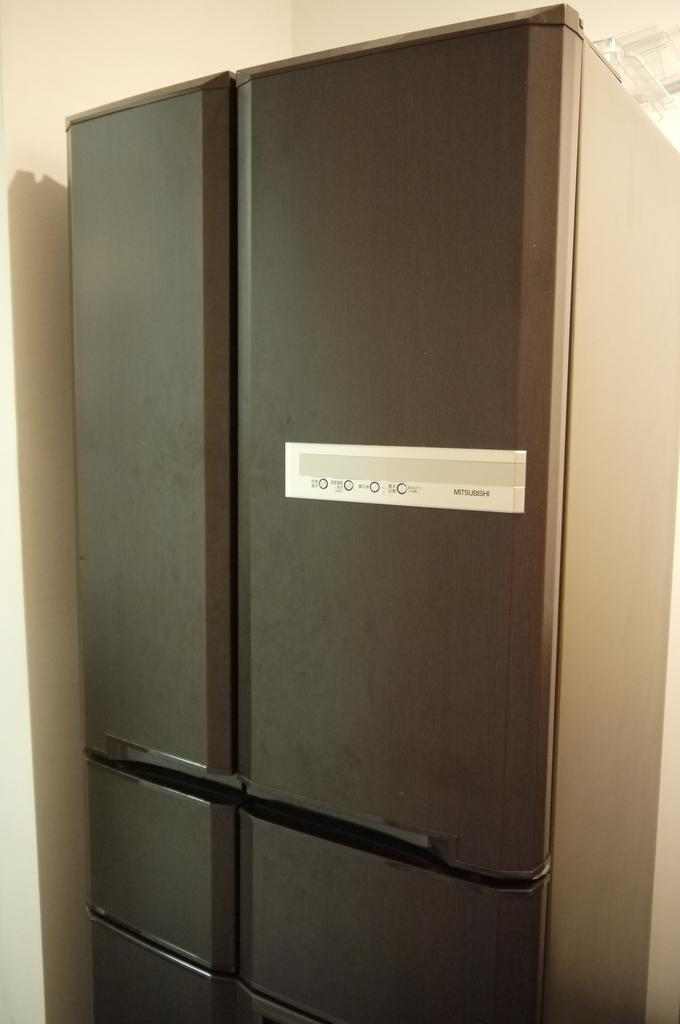<image>
Offer a succinct explanation of the picture presented. a white sign that has the title of Mitsubishi on it 